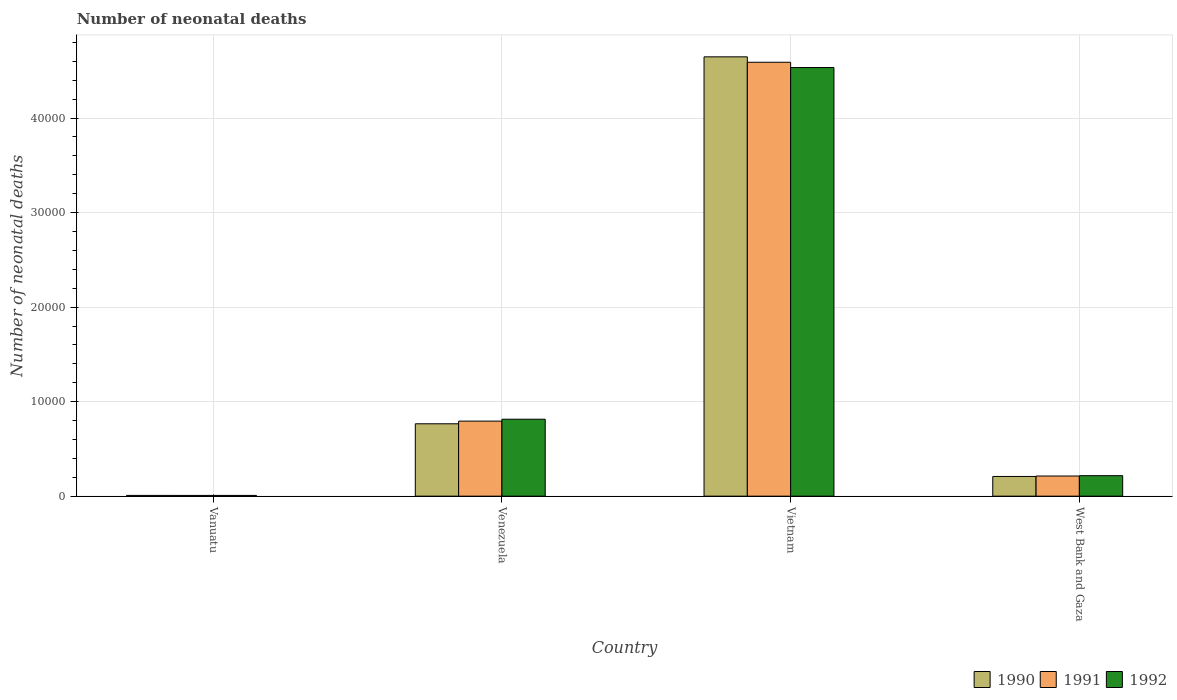How many different coloured bars are there?
Keep it short and to the point. 3. Are the number of bars per tick equal to the number of legend labels?
Offer a very short reply. Yes. How many bars are there on the 2nd tick from the left?
Provide a succinct answer. 3. How many bars are there on the 3rd tick from the right?
Provide a short and direct response. 3. What is the label of the 1st group of bars from the left?
Ensure brevity in your answer.  Vanuatu. In how many cases, is the number of bars for a given country not equal to the number of legend labels?
Ensure brevity in your answer.  0. What is the number of neonatal deaths in in 1990 in West Bank and Gaza?
Make the answer very short. 2084. Across all countries, what is the maximum number of neonatal deaths in in 1990?
Offer a terse response. 4.65e+04. Across all countries, what is the minimum number of neonatal deaths in in 1990?
Ensure brevity in your answer.  81. In which country was the number of neonatal deaths in in 1991 maximum?
Provide a short and direct response. Vietnam. In which country was the number of neonatal deaths in in 1991 minimum?
Ensure brevity in your answer.  Vanuatu. What is the total number of neonatal deaths in in 1992 in the graph?
Provide a short and direct response. 5.57e+04. What is the difference between the number of neonatal deaths in in 1992 in Vanuatu and that in Vietnam?
Provide a succinct answer. -4.53e+04. What is the difference between the number of neonatal deaths in in 1991 in Vanuatu and the number of neonatal deaths in in 1990 in Vietnam?
Your answer should be compact. -4.64e+04. What is the average number of neonatal deaths in in 1990 per country?
Offer a terse response. 1.41e+04. What is the difference between the number of neonatal deaths in of/in 1991 and number of neonatal deaths in of/in 1990 in West Bank and Gaza?
Your answer should be compact. 46. In how many countries, is the number of neonatal deaths in in 1991 greater than 28000?
Make the answer very short. 1. What is the ratio of the number of neonatal deaths in in 1991 in Vanuatu to that in Venezuela?
Your answer should be compact. 0.01. Is the number of neonatal deaths in in 1992 in Vanuatu less than that in Vietnam?
Provide a short and direct response. Yes. Is the difference between the number of neonatal deaths in in 1991 in Vanuatu and Venezuela greater than the difference between the number of neonatal deaths in in 1990 in Vanuatu and Venezuela?
Ensure brevity in your answer.  No. What is the difference between the highest and the second highest number of neonatal deaths in in 1991?
Offer a very short reply. 5809. What is the difference between the highest and the lowest number of neonatal deaths in in 1992?
Make the answer very short. 4.53e+04. Is the sum of the number of neonatal deaths in in 1992 in Vietnam and West Bank and Gaza greater than the maximum number of neonatal deaths in in 1990 across all countries?
Your answer should be very brief. Yes. What does the 2nd bar from the left in Vanuatu represents?
Make the answer very short. 1991. Are all the bars in the graph horizontal?
Offer a terse response. No. How many countries are there in the graph?
Your answer should be very brief. 4. What is the difference between two consecutive major ticks on the Y-axis?
Your answer should be very brief. 10000. Where does the legend appear in the graph?
Your response must be concise. Bottom right. How many legend labels are there?
Your response must be concise. 3. What is the title of the graph?
Make the answer very short. Number of neonatal deaths. Does "1999" appear as one of the legend labels in the graph?
Keep it short and to the point. No. What is the label or title of the X-axis?
Give a very brief answer. Country. What is the label or title of the Y-axis?
Keep it short and to the point. Number of neonatal deaths. What is the Number of neonatal deaths of 1992 in Vanuatu?
Offer a terse response. 79. What is the Number of neonatal deaths of 1990 in Venezuela?
Keep it short and to the point. 7657. What is the Number of neonatal deaths in 1991 in Venezuela?
Ensure brevity in your answer.  7939. What is the Number of neonatal deaths in 1992 in Venezuela?
Your answer should be compact. 8141. What is the Number of neonatal deaths in 1990 in Vietnam?
Ensure brevity in your answer.  4.65e+04. What is the Number of neonatal deaths in 1991 in Vietnam?
Provide a succinct answer. 4.59e+04. What is the Number of neonatal deaths in 1992 in Vietnam?
Keep it short and to the point. 4.53e+04. What is the Number of neonatal deaths in 1990 in West Bank and Gaza?
Provide a short and direct response. 2084. What is the Number of neonatal deaths in 1991 in West Bank and Gaza?
Your response must be concise. 2130. What is the Number of neonatal deaths in 1992 in West Bank and Gaza?
Provide a succinct answer. 2167. Across all countries, what is the maximum Number of neonatal deaths of 1990?
Provide a succinct answer. 4.65e+04. Across all countries, what is the maximum Number of neonatal deaths of 1991?
Keep it short and to the point. 4.59e+04. Across all countries, what is the maximum Number of neonatal deaths in 1992?
Your response must be concise. 4.53e+04. Across all countries, what is the minimum Number of neonatal deaths of 1991?
Provide a succinct answer. 80. Across all countries, what is the minimum Number of neonatal deaths in 1992?
Offer a very short reply. 79. What is the total Number of neonatal deaths of 1990 in the graph?
Provide a succinct answer. 5.63e+04. What is the total Number of neonatal deaths in 1991 in the graph?
Keep it short and to the point. 5.60e+04. What is the total Number of neonatal deaths in 1992 in the graph?
Offer a very short reply. 5.57e+04. What is the difference between the Number of neonatal deaths of 1990 in Vanuatu and that in Venezuela?
Make the answer very short. -7576. What is the difference between the Number of neonatal deaths of 1991 in Vanuatu and that in Venezuela?
Give a very brief answer. -7859. What is the difference between the Number of neonatal deaths of 1992 in Vanuatu and that in Venezuela?
Your answer should be very brief. -8062. What is the difference between the Number of neonatal deaths of 1990 in Vanuatu and that in Vietnam?
Offer a very short reply. -4.64e+04. What is the difference between the Number of neonatal deaths in 1991 in Vanuatu and that in Vietnam?
Provide a short and direct response. -4.58e+04. What is the difference between the Number of neonatal deaths of 1992 in Vanuatu and that in Vietnam?
Offer a terse response. -4.53e+04. What is the difference between the Number of neonatal deaths in 1990 in Vanuatu and that in West Bank and Gaza?
Ensure brevity in your answer.  -2003. What is the difference between the Number of neonatal deaths in 1991 in Vanuatu and that in West Bank and Gaza?
Give a very brief answer. -2050. What is the difference between the Number of neonatal deaths in 1992 in Vanuatu and that in West Bank and Gaza?
Make the answer very short. -2088. What is the difference between the Number of neonatal deaths in 1990 in Venezuela and that in Vietnam?
Provide a short and direct response. -3.88e+04. What is the difference between the Number of neonatal deaths of 1991 in Venezuela and that in Vietnam?
Your answer should be compact. -3.80e+04. What is the difference between the Number of neonatal deaths in 1992 in Venezuela and that in Vietnam?
Your response must be concise. -3.72e+04. What is the difference between the Number of neonatal deaths in 1990 in Venezuela and that in West Bank and Gaza?
Provide a succinct answer. 5573. What is the difference between the Number of neonatal deaths in 1991 in Venezuela and that in West Bank and Gaza?
Offer a terse response. 5809. What is the difference between the Number of neonatal deaths in 1992 in Venezuela and that in West Bank and Gaza?
Offer a very short reply. 5974. What is the difference between the Number of neonatal deaths in 1990 in Vietnam and that in West Bank and Gaza?
Your answer should be compact. 4.44e+04. What is the difference between the Number of neonatal deaths of 1991 in Vietnam and that in West Bank and Gaza?
Your answer should be compact. 4.38e+04. What is the difference between the Number of neonatal deaths in 1992 in Vietnam and that in West Bank and Gaza?
Ensure brevity in your answer.  4.32e+04. What is the difference between the Number of neonatal deaths in 1990 in Vanuatu and the Number of neonatal deaths in 1991 in Venezuela?
Your answer should be compact. -7858. What is the difference between the Number of neonatal deaths in 1990 in Vanuatu and the Number of neonatal deaths in 1992 in Venezuela?
Provide a short and direct response. -8060. What is the difference between the Number of neonatal deaths of 1991 in Vanuatu and the Number of neonatal deaths of 1992 in Venezuela?
Keep it short and to the point. -8061. What is the difference between the Number of neonatal deaths of 1990 in Vanuatu and the Number of neonatal deaths of 1991 in Vietnam?
Your answer should be compact. -4.58e+04. What is the difference between the Number of neonatal deaths of 1990 in Vanuatu and the Number of neonatal deaths of 1992 in Vietnam?
Provide a succinct answer. -4.53e+04. What is the difference between the Number of neonatal deaths in 1991 in Vanuatu and the Number of neonatal deaths in 1992 in Vietnam?
Keep it short and to the point. -4.53e+04. What is the difference between the Number of neonatal deaths in 1990 in Vanuatu and the Number of neonatal deaths in 1991 in West Bank and Gaza?
Keep it short and to the point. -2049. What is the difference between the Number of neonatal deaths of 1990 in Vanuatu and the Number of neonatal deaths of 1992 in West Bank and Gaza?
Provide a short and direct response. -2086. What is the difference between the Number of neonatal deaths of 1991 in Vanuatu and the Number of neonatal deaths of 1992 in West Bank and Gaza?
Ensure brevity in your answer.  -2087. What is the difference between the Number of neonatal deaths of 1990 in Venezuela and the Number of neonatal deaths of 1991 in Vietnam?
Provide a short and direct response. -3.82e+04. What is the difference between the Number of neonatal deaths of 1990 in Venezuela and the Number of neonatal deaths of 1992 in Vietnam?
Your answer should be compact. -3.77e+04. What is the difference between the Number of neonatal deaths of 1991 in Venezuela and the Number of neonatal deaths of 1992 in Vietnam?
Make the answer very short. -3.74e+04. What is the difference between the Number of neonatal deaths in 1990 in Venezuela and the Number of neonatal deaths in 1991 in West Bank and Gaza?
Provide a short and direct response. 5527. What is the difference between the Number of neonatal deaths in 1990 in Venezuela and the Number of neonatal deaths in 1992 in West Bank and Gaza?
Give a very brief answer. 5490. What is the difference between the Number of neonatal deaths of 1991 in Venezuela and the Number of neonatal deaths of 1992 in West Bank and Gaza?
Your answer should be very brief. 5772. What is the difference between the Number of neonatal deaths in 1990 in Vietnam and the Number of neonatal deaths in 1991 in West Bank and Gaza?
Your answer should be very brief. 4.43e+04. What is the difference between the Number of neonatal deaths of 1990 in Vietnam and the Number of neonatal deaths of 1992 in West Bank and Gaza?
Ensure brevity in your answer.  4.43e+04. What is the difference between the Number of neonatal deaths in 1991 in Vietnam and the Number of neonatal deaths in 1992 in West Bank and Gaza?
Your response must be concise. 4.37e+04. What is the average Number of neonatal deaths in 1990 per country?
Your answer should be very brief. 1.41e+04. What is the average Number of neonatal deaths in 1991 per country?
Your answer should be very brief. 1.40e+04. What is the average Number of neonatal deaths in 1992 per country?
Your answer should be very brief. 1.39e+04. What is the difference between the Number of neonatal deaths in 1991 and Number of neonatal deaths in 1992 in Vanuatu?
Keep it short and to the point. 1. What is the difference between the Number of neonatal deaths of 1990 and Number of neonatal deaths of 1991 in Venezuela?
Give a very brief answer. -282. What is the difference between the Number of neonatal deaths of 1990 and Number of neonatal deaths of 1992 in Venezuela?
Your answer should be very brief. -484. What is the difference between the Number of neonatal deaths in 1991 and Number of neonatal deaths in 1992 in Venezuela?
Give a very brief answer. -202. What is the difference between the Number of neonatal deaths in 1990 and Number of neonatal deaths in 1991 in Vietnam?
Offer a terse response. 574. What is the difference between the Number of neonatal deaths of 1990 and Number of neonatal deaths of 1992 in Vietnam?
Ensure brevity in your answer.  1131. What is the difference between the Number of neonatal deaths in 1991 and Number of neonatal deaths in 1992 in Vietnam?
Provide a short and direct response. 557. What is the difference between the Number of neonatal deaths of 1990 and Number of neonatal deaths of 1991 in West Bank and Gaza?
Offer a very short reply. -46. What is the difference between the Number of neonatal deaths in 1990 and Number of neonatal deaths in 1992 in West Bank and Gaza?
Keep it short and to the point. -83. What is the difference between the Number of neonatal deaths in 1991 and Number of neonatal deaths in 1992 in West Bank and Gaza?
Your response must be concise. -37. What is the ratio of the Number of neonatal deaths of 1990 in Vanuatu to that in Venezuela?
Ensure brevity in your answer.  0.01. What is the ratio of the Number of neonatal deaths of 1991 in Vanuatu to that in Venezuela?
Make the answer very short. 0.01. What is the ratio of the Number of neonatal deaths in 1992 in Vanuatu to that in Venezuela?
Your answer should be compact. 0.01. What is the ratio of the Number of neonatal deaths in 1990 in Vanuatu to that in Vietnam?
Your response must be concise. 0. What is the ratio of the Number of neonatal deaths of 1991 in Vanuatu to that in Vietnam?
Give a very brief answer. 0. What is the ratio of the Number of neonatal deaths of 1992 in Vanuatu to that in Vietnam?
Give a very brief answer. 0. What is the ratio of the Number of neonatal deaths in 1990 in Vanuatu to that in West Bank and Gaza?
Your response must be concise. 0.04. What is the ratio of the Number of neonatal deaths of 1991 in Vanuatu to that in West Bank and Gaza?
Your answer should be very brief. 0.04. What is the ratio of the Number of neonatal deaths in 1992 in Vanuatu to that in West Bank and Gaza?
Your response must be concise. 0.04. What is the ratio of the Number of neonatal deaths in 1990 in Venezuela to that in Vietnam?
Make the answer very short. 0.16. What is the ratio of the Number of neonatal deaths in 1991 in Venezuela to that in Vietnam?
Provide a succinct answer. 0.17. What is the ratio of the Number of neonatal deaths in 1992 in Venezuela to that in Vietnam?
Your answer should be very brief. 0.18. What is the ratio of the Number of neonatal deaths in 1990 in Venezuela to that in West Bank and Gaza?
Offer a very short reply. 3.67. What is the ratio of the Number of neonatal deaths in 1991 in Venezuela to that in West Bank and Gaza?
Offer a terse response. 3.73. What is the ratio of the Number of neonatal deaths of 1992 in Venezuela to that in West Bank and Gaza?
Your response must be concise. 3.76. What is the ratio of the Number of neonatal deaths in 1990 in Vietnam to that in West Bank and Gaza?
Give a very brief answer. 22.3. What is the ratio of the Number of neonatal deaths of 1991 in Vietnam to that in West Bank and Gaza?
Keep it short and to the point. 21.55. What is the ratio of the Number of neonatal deaths in 1992 in Vietnam to that in West Bank and Gaza?
Offer a terse response. 20.92. What is the difference between the highest and the second highest Number of neonatal deaths of 1990?
Offer a terse response. 3.88e+04. What is the difference between the highest and the second highest Number of neonatal deaths of 1991?
Make the answer very short. 3.80e+04. What is the difference between the highest and the second highest Number of neonatal deaths of 1992?
Offer a very short reply. 3.72e+04. What is the difference between the highest and the lowest Number of neonatal deaths of 1990?
Provide a succinct answer. 4.64e+04. What is the difference between the highest and the lowest Number of neonatal deaths in 1991?
Offer a terse response. 4.58e+04. What is the difference between the highest and the lowest Number of neonatal deaths in 1992?
Your response must be concise. 4.53e+04. 